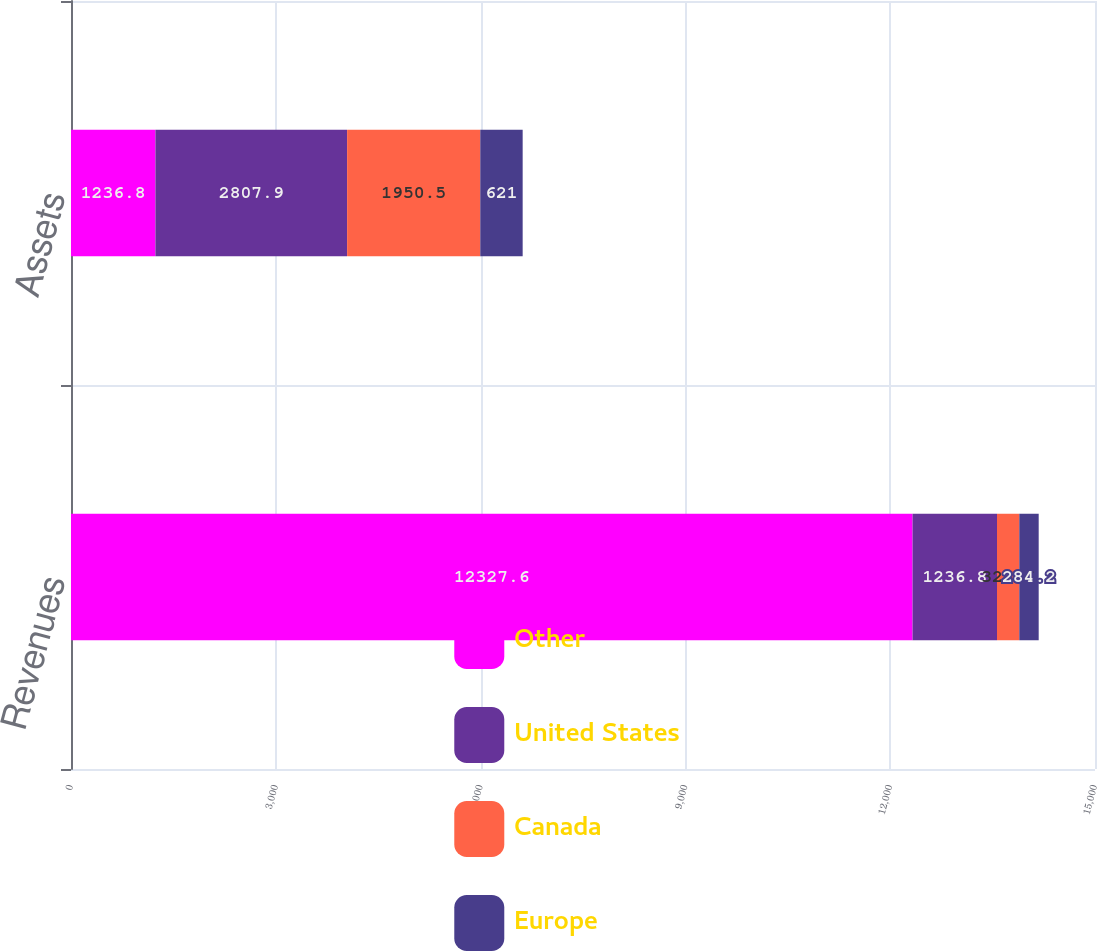<chart> <loc_0><loc_0><loc_500><loc_500><stacked_bar_chart><ecel><fcel>Revenues<fcel>Assets<nl><fcel>Other<fcel>12327.6<fcel>1236.8<nl><fcel>United States<fcel>1236.8<fcel>2807.9<nl><fcel>Canada<fcel>326.6<fcel>1950.5<nl><fcel>Europe<fcel>284.2<fcel>621<nl></chart> 